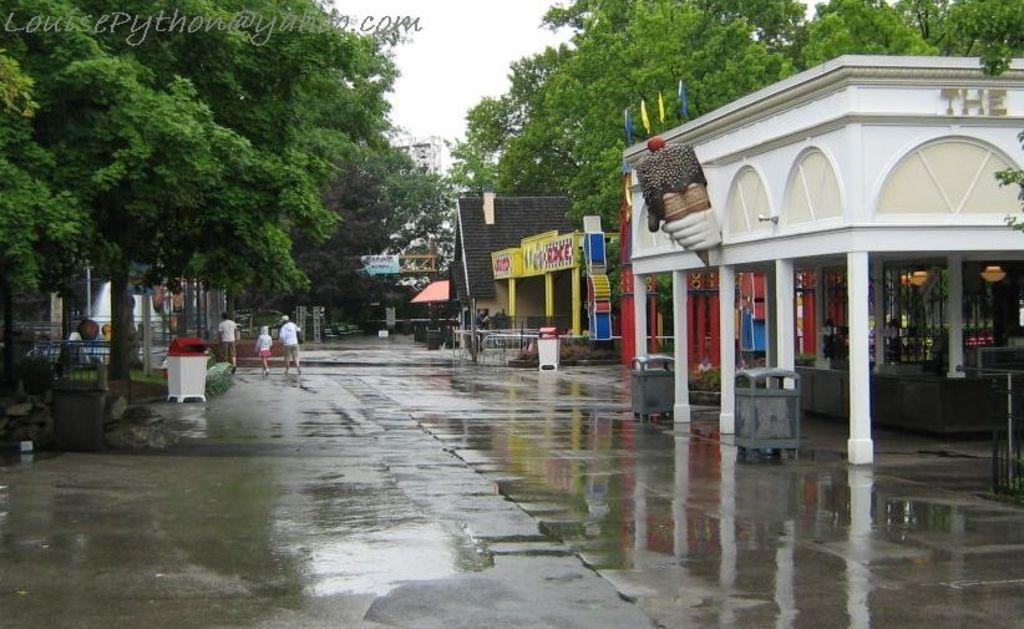Please provide a concise description of this image. The picture is taken outside on the road where at the right corner one ice cream parlour is present and in front of that there are two dustbins are placed and beside that there are another buildings are present and coming to the left corner of the picture three people are walking on the road where one white colour dust bin is present and there are trees which are surrounded the buildings. 